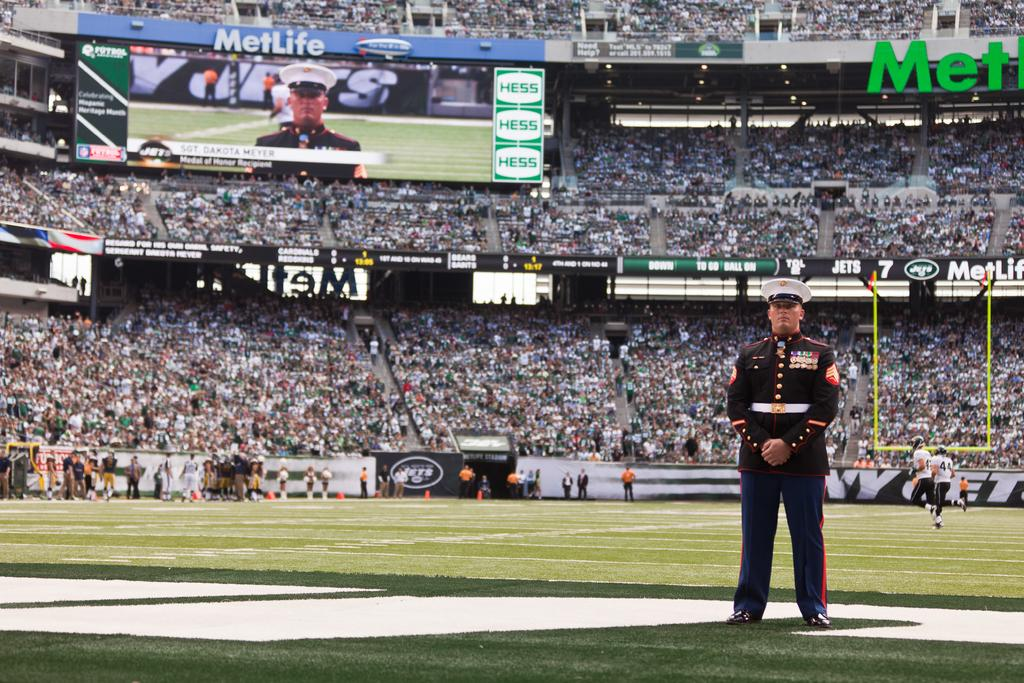<image>
Describe the image concisely. A sports stadium with a lot of Metlife advertisements 